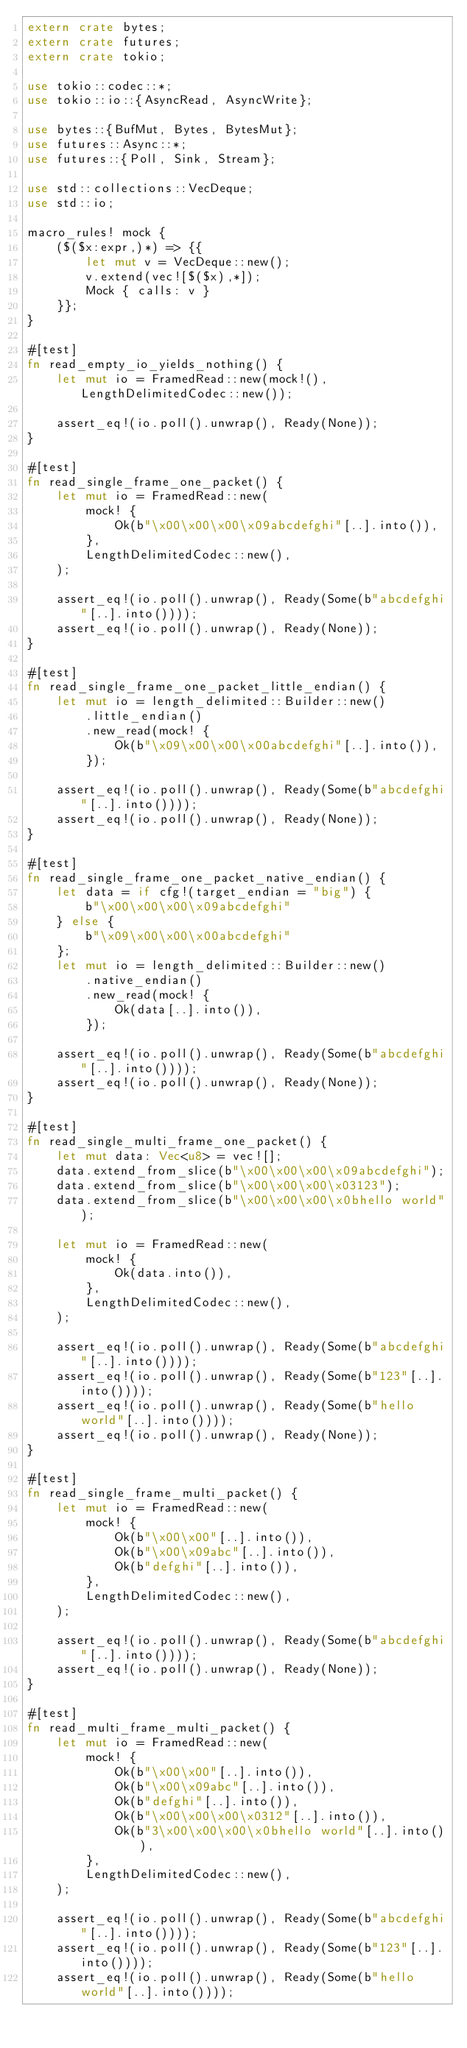<code> <loc_0><loc_0><loc_500><loc_500><_Rust_>extern crate bytes;
extern crate futures;
extern crate tokio;

use tokio::codec::*;
use tokio::io::{AsyncRead, AsyncWrite};

use bytes::{BufMut, Bytes, BytesMut};
use futures::Async::*;
use futures::{Poll, Sink, Stream};

use std::collections::VecDeque;
use std::io;

macro_rules! mock {
    ($($x:expr,)*) => {{
        let mut v = VecDeque::new();
        v.extend(vec![$($x),*]);
        Mock { calls: v }
    }};
}

#[test]
fn read_empty_io_yields_nothing() {
    let mut io = FramedRead::new(mock!(), LengthDelimitedCodec::new());

    assert_eq!(io.poll().unwrap(), Ready(None));
}

#[test]
fn read_single_frame_one_packet() {
    let mut io = FramedRead::new(
        mock! {
            Ok(b"\x00\x00\x00\x09abcdefghi"[..].into()),
        },
        LengthDelimitedCodec::new(),
    );

    assert_eq!(io.poll().unwrap(), Ready(Some(b"abcdefghi"[..].into())));
    assert_eq!(io.poll().unwrap(), Ready(None));
}

#[test]
fn read_single_frame_one_packet_little_endian() {
    let mut io = length_delimited::Builder::new()
        .little_endian()
        .new_read(mock! {
            Ok(b"\x09\x00\x00\x00abcdefghi"[..].into()),
        });

    assert_eq!(io.poll().unwrap(), Ready(Some(b"abcdefghi"[..].into())));
    assert_eq!(io.poll().unwrap(), Ready(None));
}

#[test]
fn read_single_frame_one_packet_native_endian() {
    let data = if cfg!(target_endian = "big") {
        b"\x00\x00\x00\x09abcdefghi"
    } else {
        b"\x09\x00\x00\x00abcdefghi"
    };
    let mut io = length_delimited::Builder::new()
        .native_endian()
        .new_read(mock! {
            Ok(data[..].into()),
        });

    assert_eq!(io.poll().unwrap(), Ready(Some(b"abcdefghi"[..].into())));
    assert_eq!(io.poll().unwrap(), Ready(None));
}

#[test]
fn read_single_multi_frame_one_packet() {
    let mut data: Vec<u8> = vec![];
    data.extend_from_slice(b"\x00\x00\x00\x09abcdefghi");
    data.extend_from_slice(b"\x00\x00\x00\x03123");
    data.extend_from_slice(b"\x00\x00\x00\x0bhello world");

    let mut io = FramedRead::new(
        mock! {
            Ok(data.into()),
        },
        LengthDelimitedCodec::new(),
    );

    assert_eq!(io.poll().unwrap(), Ready(Some(b"abcdefghi"[..].into())));
    assert_eq!(io.poll().unwrap(), Ready(Some(b"123"[..].into())));
    assert_eq!(io.poll().unwrap(), Ready(Some(b"hello world"[..].into())));
    assert_eq!(io.poll().unwrap(), Ready(None));
}

#[test]
fn read_single_frame_multi_packet() {
    let mut io = FramedRead::new(
        mock! {
            Ok(b"\x00\x00"[..].into()),
            Ok(b"\x00\x09abc"[..].into()),
            Ok(b"defghi"[..].into()),
        },
        LengthDelimitedCodec::new(),
    );

    assert_eq!(io.poll().unwrap(), Ready(Some(b"abcdefghi"[..].into())));
    assert_eq!(io.poll().unwrap(), Ready(None));
}

#[test]
fn read_multi_frame_multi_packet() {
    let mut io = FramedRead::new(
        mock! {
            Ok(b"\x00\x00"[..].into()),
            Ok(b"\x00\x09abc"[..].into()),
            Ok(b"defghi"[..].into()),
            Ok(b"\x00\x00\x00\x0312"[..].into()),
            Ok(b"3\x00\x00\x00\x0bhello world"[..].into()),
        },
        LengthDelimitedCodec::new(),
    );

    assert_eq!(io.poll().unwrap(), Ready(Some(b"abcdefghi"[..].into())));
    assert_eq!(io.poll().unwrap(), Ready(Some(b"123"[..].into())));
    assert_eq!(io.poll().unwrap(), Ready(Some(b"hello world"[..].into())));</code> 